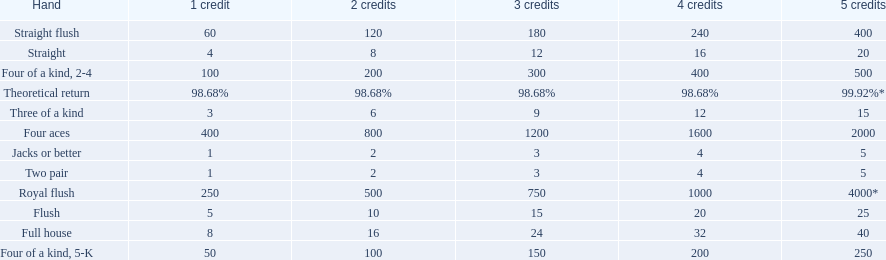What is the higher amount of points for one credit you can get from the best four of a kind 100. What type is it? Four of a kind, 2-4. 